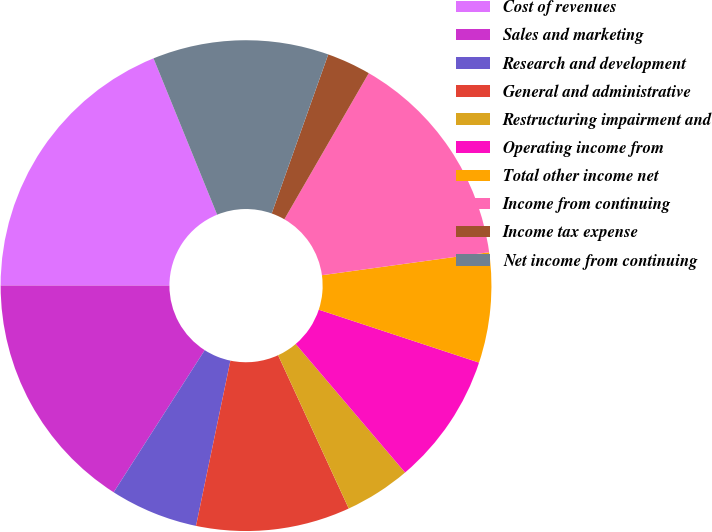Convert chart to OTSL. <chart><loc_0><loc_0><loc_500><loc_500><pie_chart><fcel>Cost of revenues<fcel>Sales and marketing<fcel>Research and development<fcel>General and administrative<fcel>Restructuring impairment and<fcel>Operating income from<fcel>Total other income net<fcel>Income from continuing<fcel>Income tax expense<fcel>Net income from continuing<nl><fcel>18.84%<fcel>15.94%<fcel>5.8%<fcel>10.14%<fcel>4.35%<fcel>8.7%<fcel>7.25%<fcel>14.49%<fcel>2.9%<fcel>11.59%<nl></chart> 